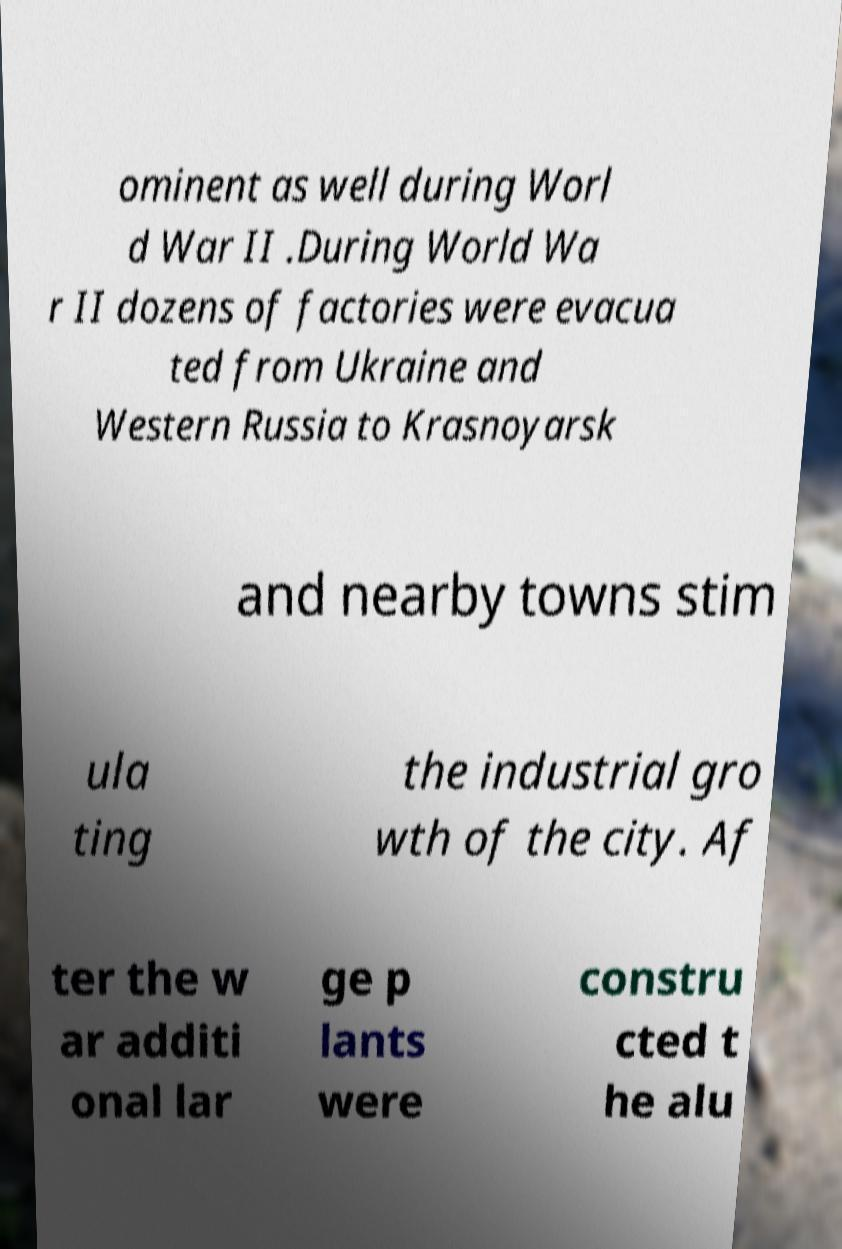What messages or text are displayed in this image? I need them in a readable, typed format. ominent as well during Worl d War II .During World Wa r II dozens of factories were evacua ted from Ukraine and Western Russia to Krasnoyarsk and nearby towns stim ula ting the industrial gro wth of the city. Af ter the w ar additi onal lar ge p lants were constru cted t he alu 